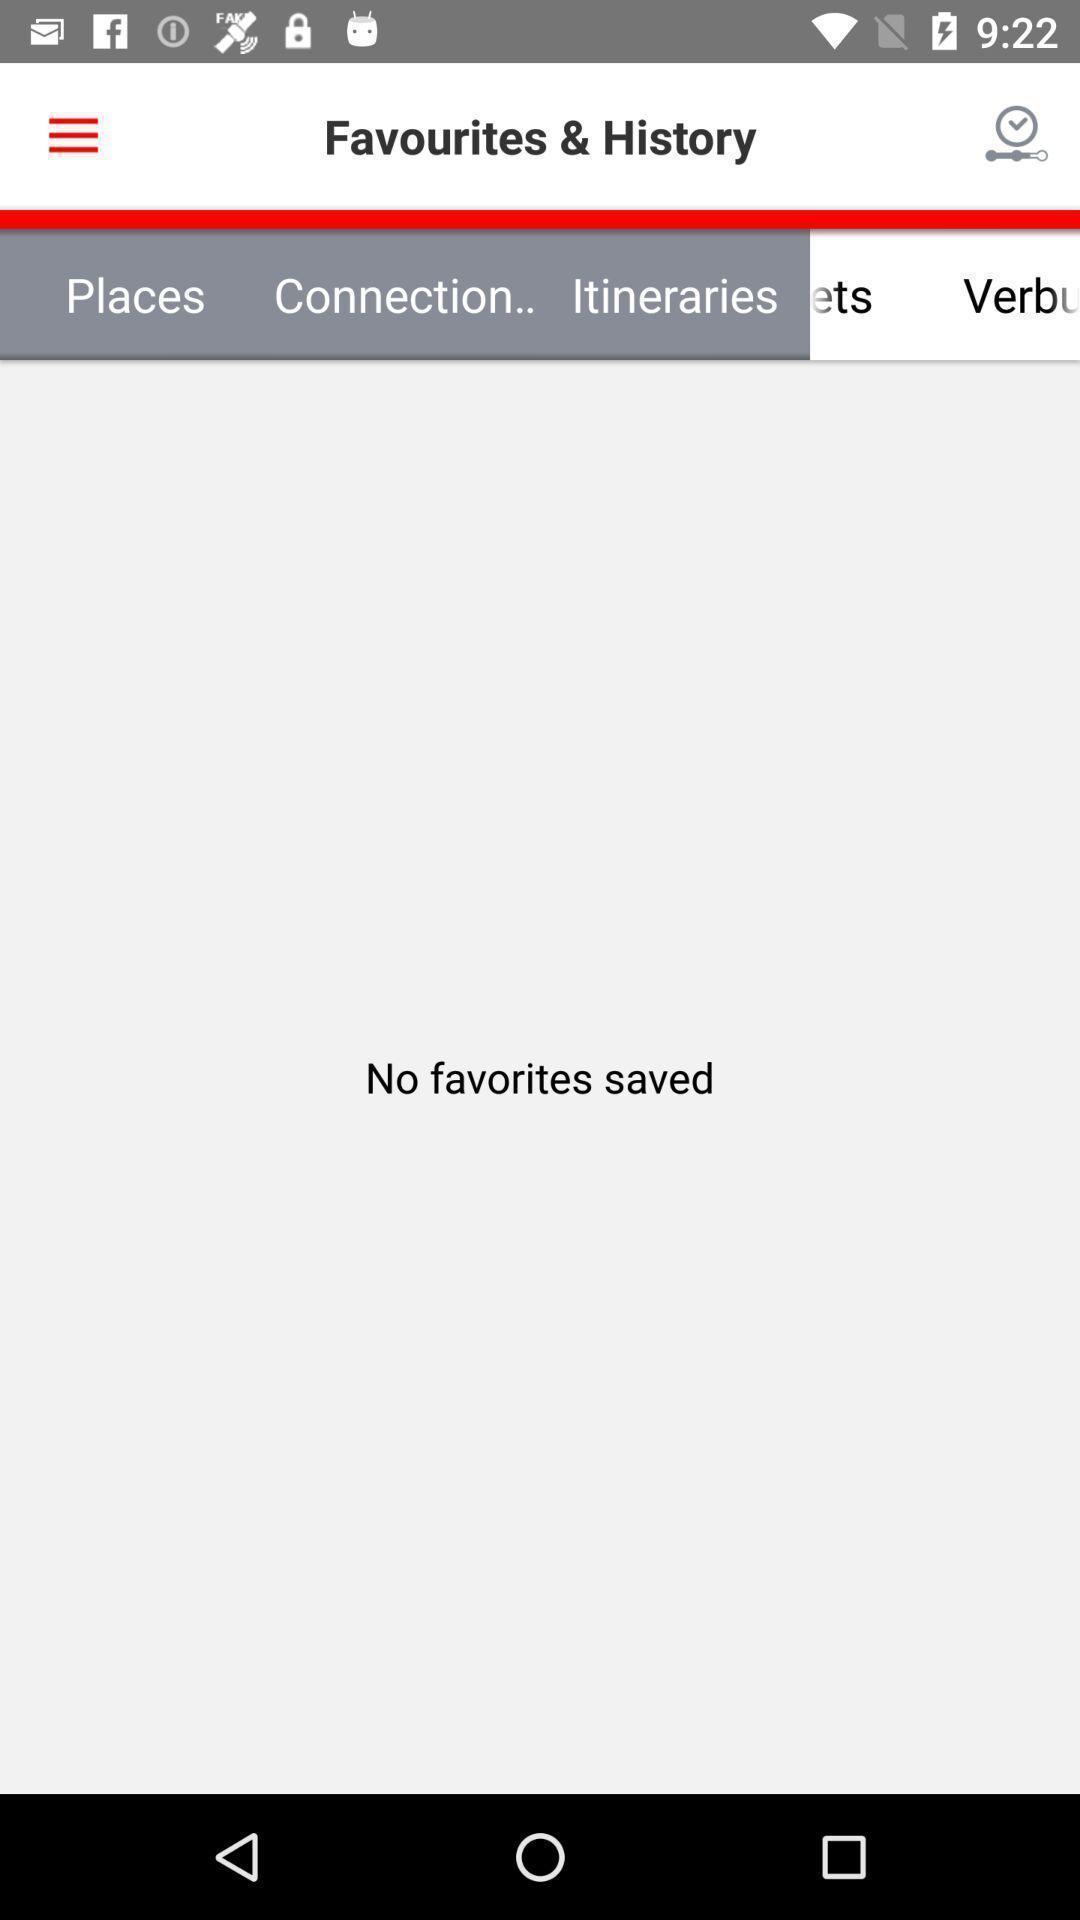What is the overall content of this screenshot? Page showing the favourites history. 